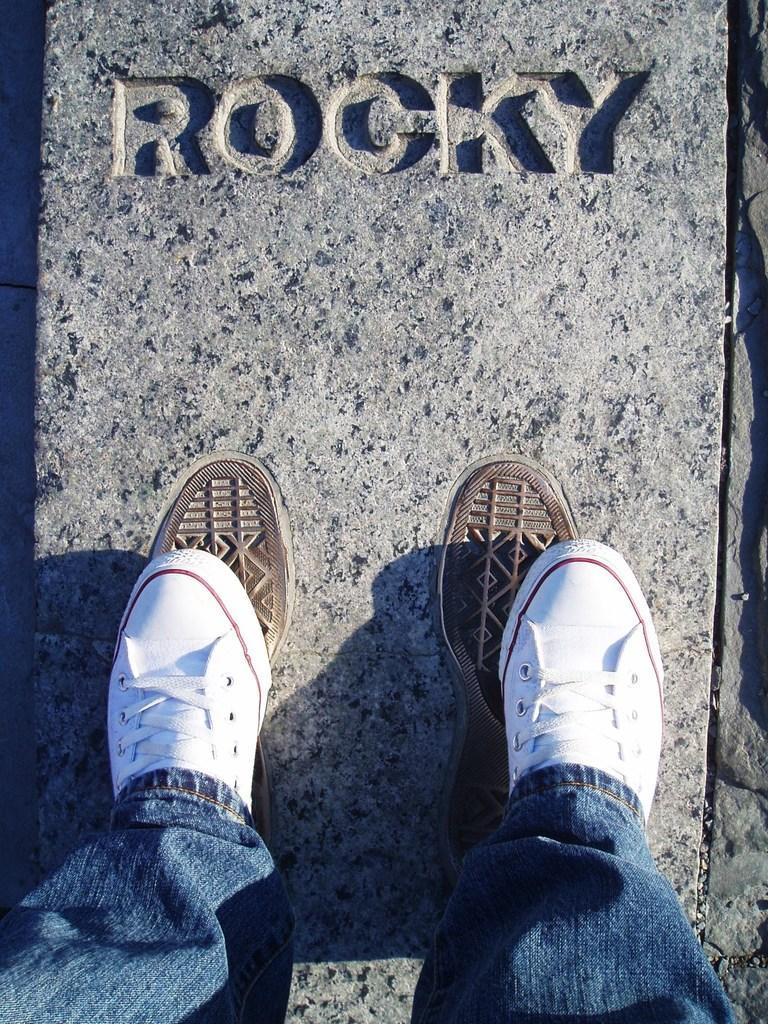How would you summarize this image in a sentence or two? In this image we can see a person standing on the surface and we can also see some text written on it. 